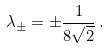Convert formula to latex. <formula><loc_0><loc_0><loc_500><loc_500>\lambda _ { \pm } = \pm \frac { 1 } { 8 \sqrt { 2 } } \, .</formula> 